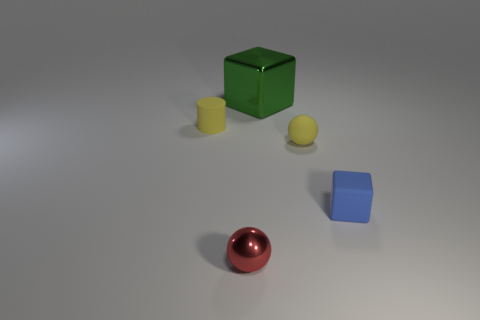Add 5 tiny red balls. How many objects exist? 10 Subtract all blocks. How many objects are left? 3 Subtract 0 cyan blocks. How many objects are left? 5 Subtract all small purple rubber cylinders. Subtract all tiny matte balls. How many objects are left? 4 Add 3 large green blocks. How many large green blocks are left? 4 Add 3 large metallic cubes. How many large metallic cubes exist? 4 